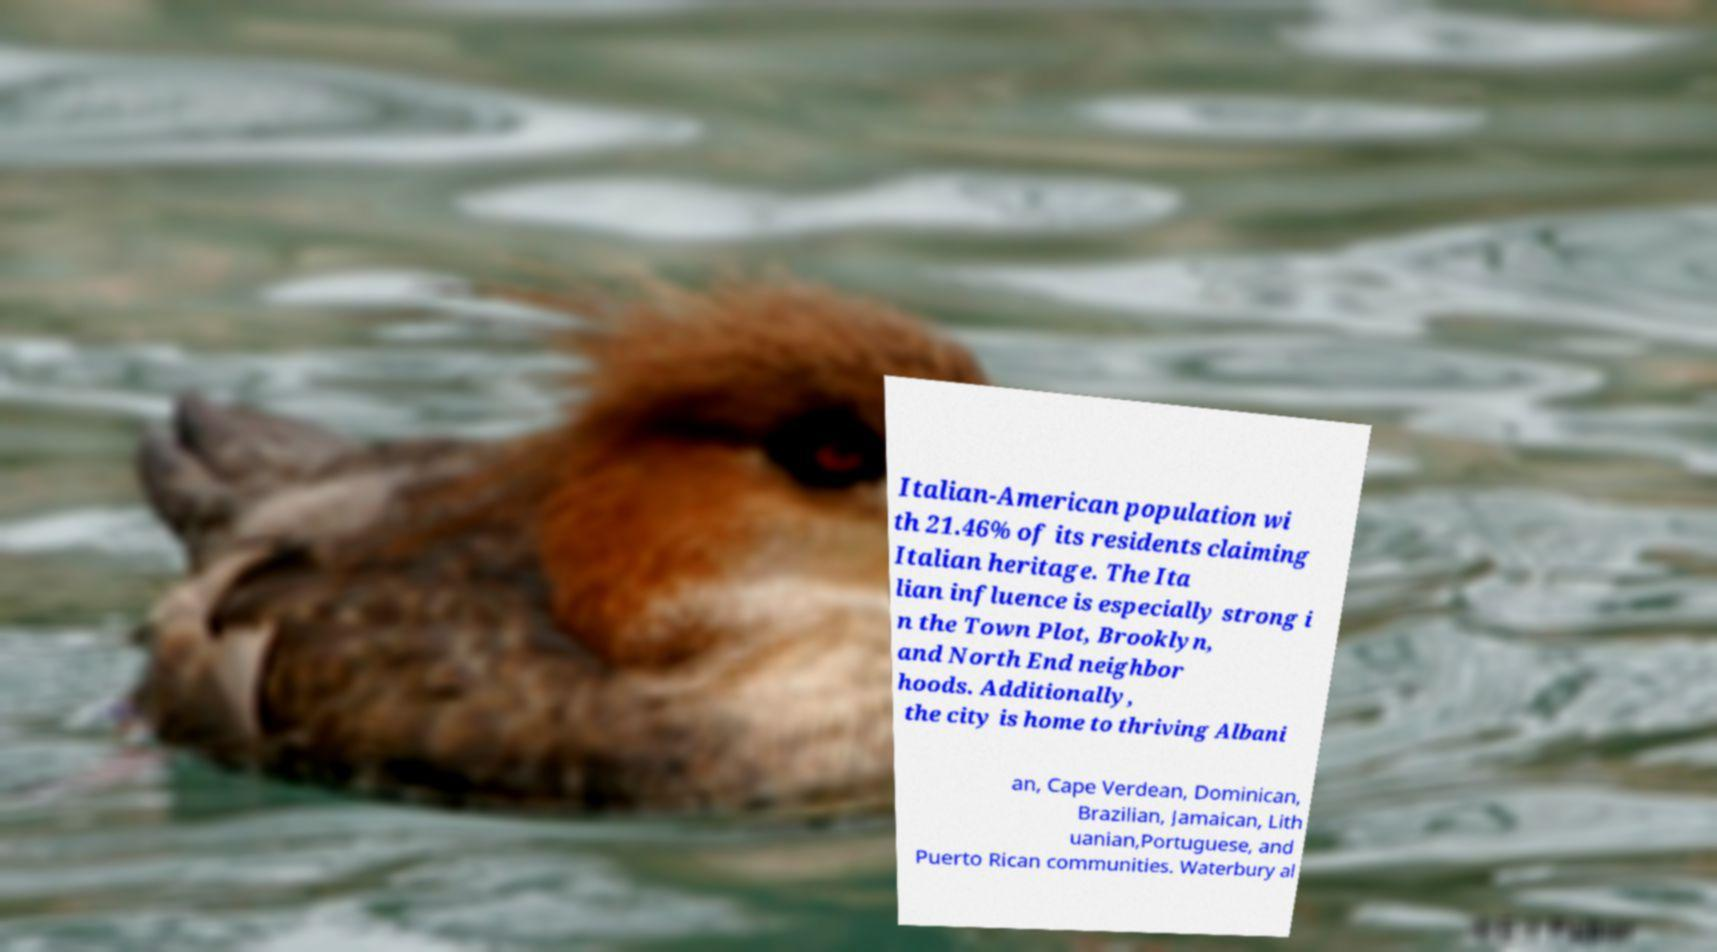What messages or text are displayed in this image? I need them in a readable, typed format. Italian-American population wi th 21.46% of its residents claiming Italian heritage. The Ita lian influence is especially strong i n the Town Plot, Brooklyn, and North End neighbor hoods. Additionally, the city is home to thriving Albani an, Cape Verdean, Dominican, Brazilian, Jamaican, Lith uanian,Portuguese, and Puerto Rican communities. Waterbury al 